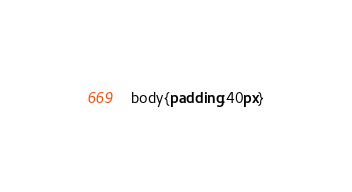<code> <loc_0><loc_0><loc_500><loc_500><_CSS_>body{padding:40px}</code> 